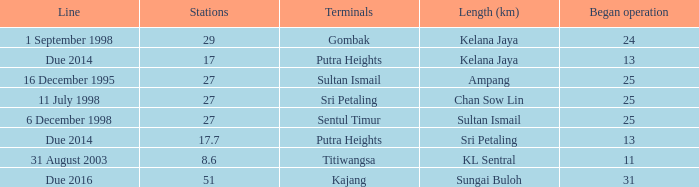When is the earliest began operation with a length of sultan ismail and over 27 stations? None. 